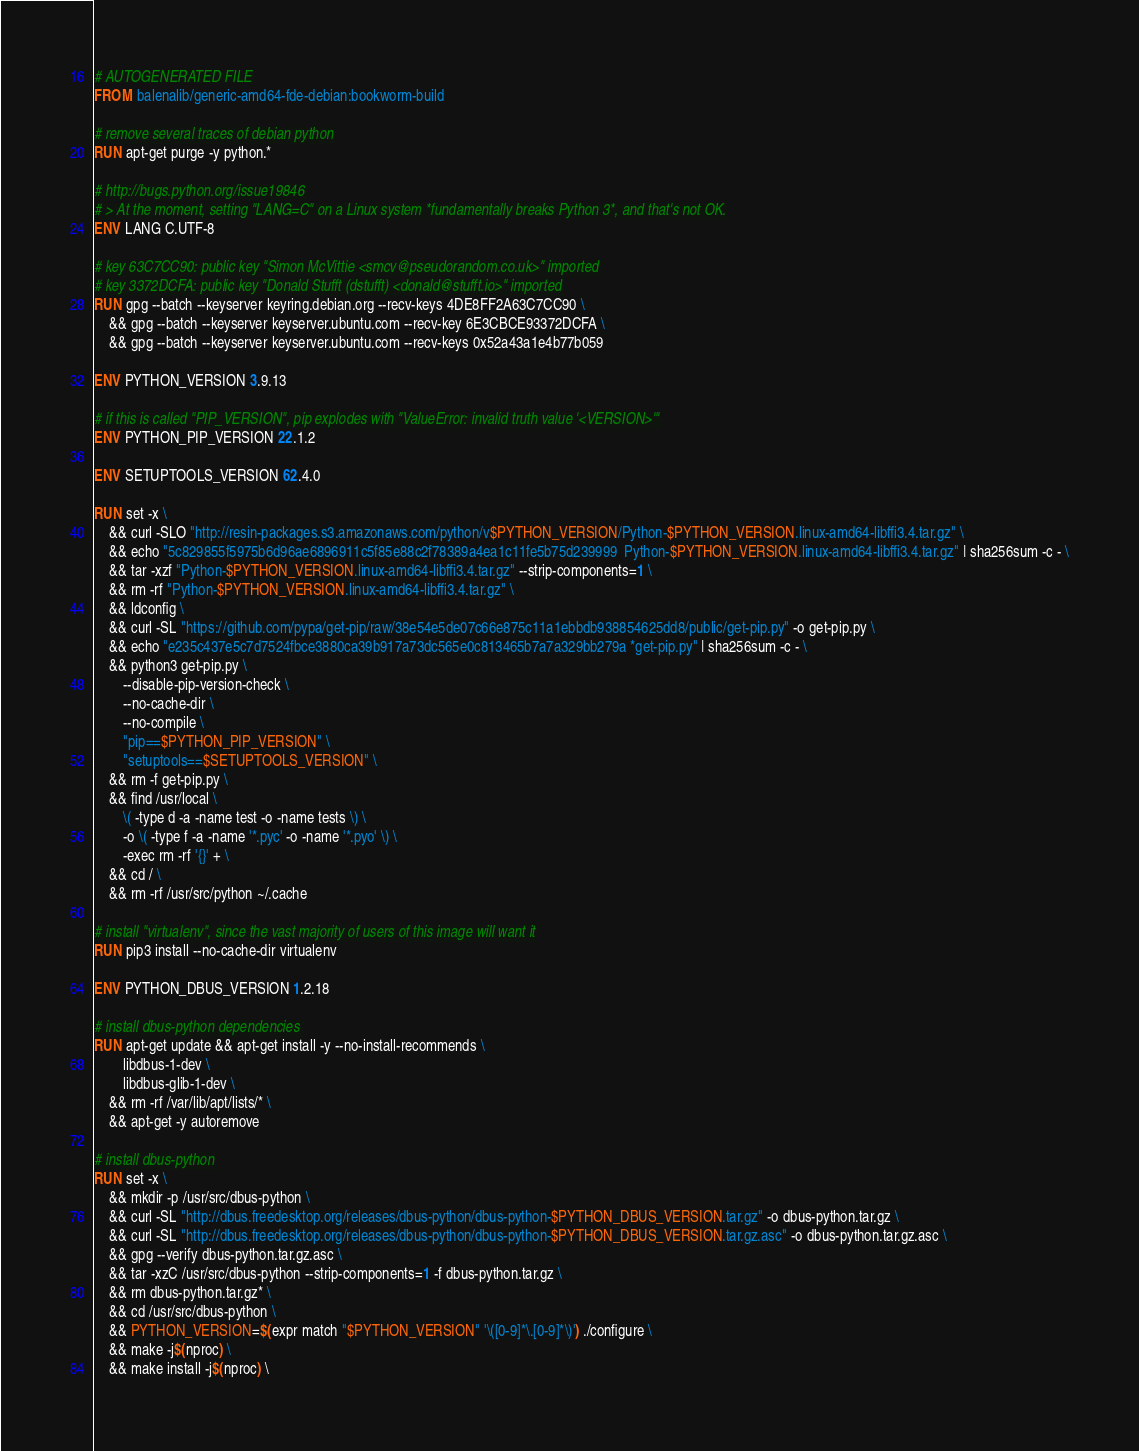Convert code to text. <code><loc_0><loc_0><loc_500><loc_500><_Dockerfile_># AUTOGENERATED FILE
FROM balenalib/generic-amd64-fde-debian:bookworm-build

# remove several traces of debian python
RUN apt-get purge -y python.*

# http://bugs.python.org/issue19846
# > At the moment, setting "LANG=C" on a Linux system *fundamentally breaks Python 3*, and that's not OK.
ENV LANG C.UTF-8

# key 63C7CC90: public key "Simon McVittie <smcv@pseudorandom.co.uk>" imported
# key 3372DCFA: public key "Donald Stufft (dstufft) <donald@stufft.io>" imported
RUN gpg --batch --keyserver keyring.debian.org --recv-keys 4DE8FF2A63C7CC90 \
    && gpg --batch --keyserver keyserver.ubuntu.com --recv-key 6E3CBCE93372DCFA \
    && gpg --batch --keyserver keyserver.ubuntu.com --recv-keys 0x52a43a1e4b77b059

ENV PYTHON_VERSION 3.9.13

# if this is called "PIP_VERSION", pip explodes with "ValueError: invalid truth value '<VERSION>'"
ENV PYTHON_PIP_VERSION 22.1.2

ENV SETUPTOOLS_VERSION 62.4.0

RUN set -x \
    && curl -SLO "http://resin-packages.s3.amazonaws.com/python/v$PYTHON_VERSION/Python-$PYTHON_VERSION.linux-amd64-libffi3.4.tar.gz" \
    && echo "5c829855f5975b6d96ae6896911c5f85e88c2f78389a4ea1c11fe5b75d239999  Python-$PYTHON_VERSION.linux-amd64-libffi3.4.tar.gz" | sha256sum -c - \
    && tar -xzf "Python-$PYTHON_VERSION.linux-amd64-libffi3.4.tar.gz" --strip-components=1 \
    && rm -rf "Python-$PYTHON_VERSION.linux-amd64-libffi3.4.tar.gz" \
    && ldconfig \
    && curl -SL "https://github.com/pypa/get-pip/raw/38e54e5de07c66e875c11a1ebbdb938854625dd8/public/get-pip.py" -o get-pip.py \
    && echo "e235c437e5c7d7524fbce3880ca39b917a73dc565e0c813465b7a7a329bb279a *get-pip.py" | sha256sum -c - \
    && python3 get-pip.py \
        --disable-pip-version-check \
        --no-cache-dir \
        --no-compile \
        "pip==$PYTHON_PIP_VERSION" \
        "setuptools==$SETUPTOOLS_VERSION" \
    && rm -f get-pip.py \
    && find /usr/local \
        \( -type d -a -name test -o -name tests \) \
        -o \( -type f -a -name '*.pyc' -o -name '*.pyo' \) \
        -exec rm -rf '{}' + \
    && cd / \
    && rm -rf /usr/src/python ~/.cache

# install "virtualenv", since the vast majority of users of this image will want it
RUN pip3 install --no-cache-dir virtualenv

ENV PYTHON_DBUS_VERSION 1.2.18

# install dbus-python dependencies 
RUN apt-get update && apt-get install -y --no-install-recommends \
		libdbus-1-dev \
		libdbus-glib-1-dev \
	&& rm -rf /var/lib/apt/lists/* \
	&& apt-get -y autoremove

# install dbus-python
RUN set -x \
	&& mkdir -p /usr/src/dbus-python \
	&& curl -SL "http://dbus.freedesktop.org/releases/dbus-python/dbus-python-$PYTHON_DBUS_VERSION.tar.gz" -o dbus-python.tar.gz \
	&& curl -SL "http://dbus.freedesktop.org/releases/dbus-python/dbus-python-$PYTHON_DBUS_VERSION.tar.gz.asc" -o dbus-python.tar.gz.asc \
	&& gpg --verify dbus-python.tar.gz.asc \
	&& tar -xzC /usr/src/dbus-python --strip-components=1 -f dbus-python.tar.gz \
	&& rm dbus-python.tar.gz* \
	&& cd /usr/src/dbus-python \
	&& PYTHON_VERSION=$(expr match "$PYTHON_VERSION" '\([0-9]*\.[0-9]*\)') ./configure \
	&& make -j$(nproc) \
	&& make install -j$(nproc) \</code> 